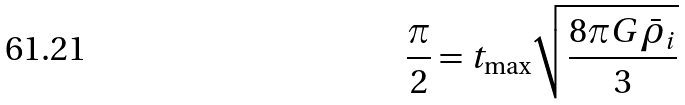Convert formula to latex. <formula><loc_0><loc_0><loc_500><loc_500>\frac { \pi } { 2 } = t _ { \max } \sqrt { \frac { 8 \pi G \bar { \rho } _ { i } } { 3 } }</formula> 